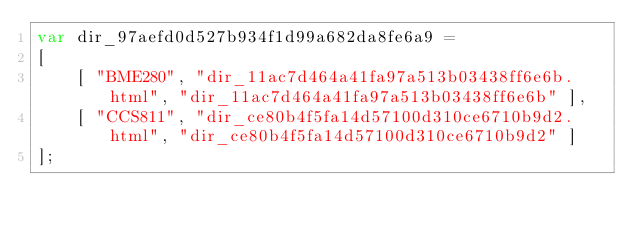<code> <loc_0><loc_0><loc_500><loc_500><_JavaScript_>var dir_97aefd0d527b934f1d99a682da8fe6a9 =
[
    [ "BME280", "dir_11ac7d464a41fa97a513b03438ff6e6b.html", "dir_11ac7d464a41fa97a513b03438ff6e6b" ],
    [ "CCS811", "dir_ce80b4f5fa14d57100d310ce6710b9d2.html", "dir_ce80b4f5fa14d57100d310ce6710b9d2" ]
];</code> 